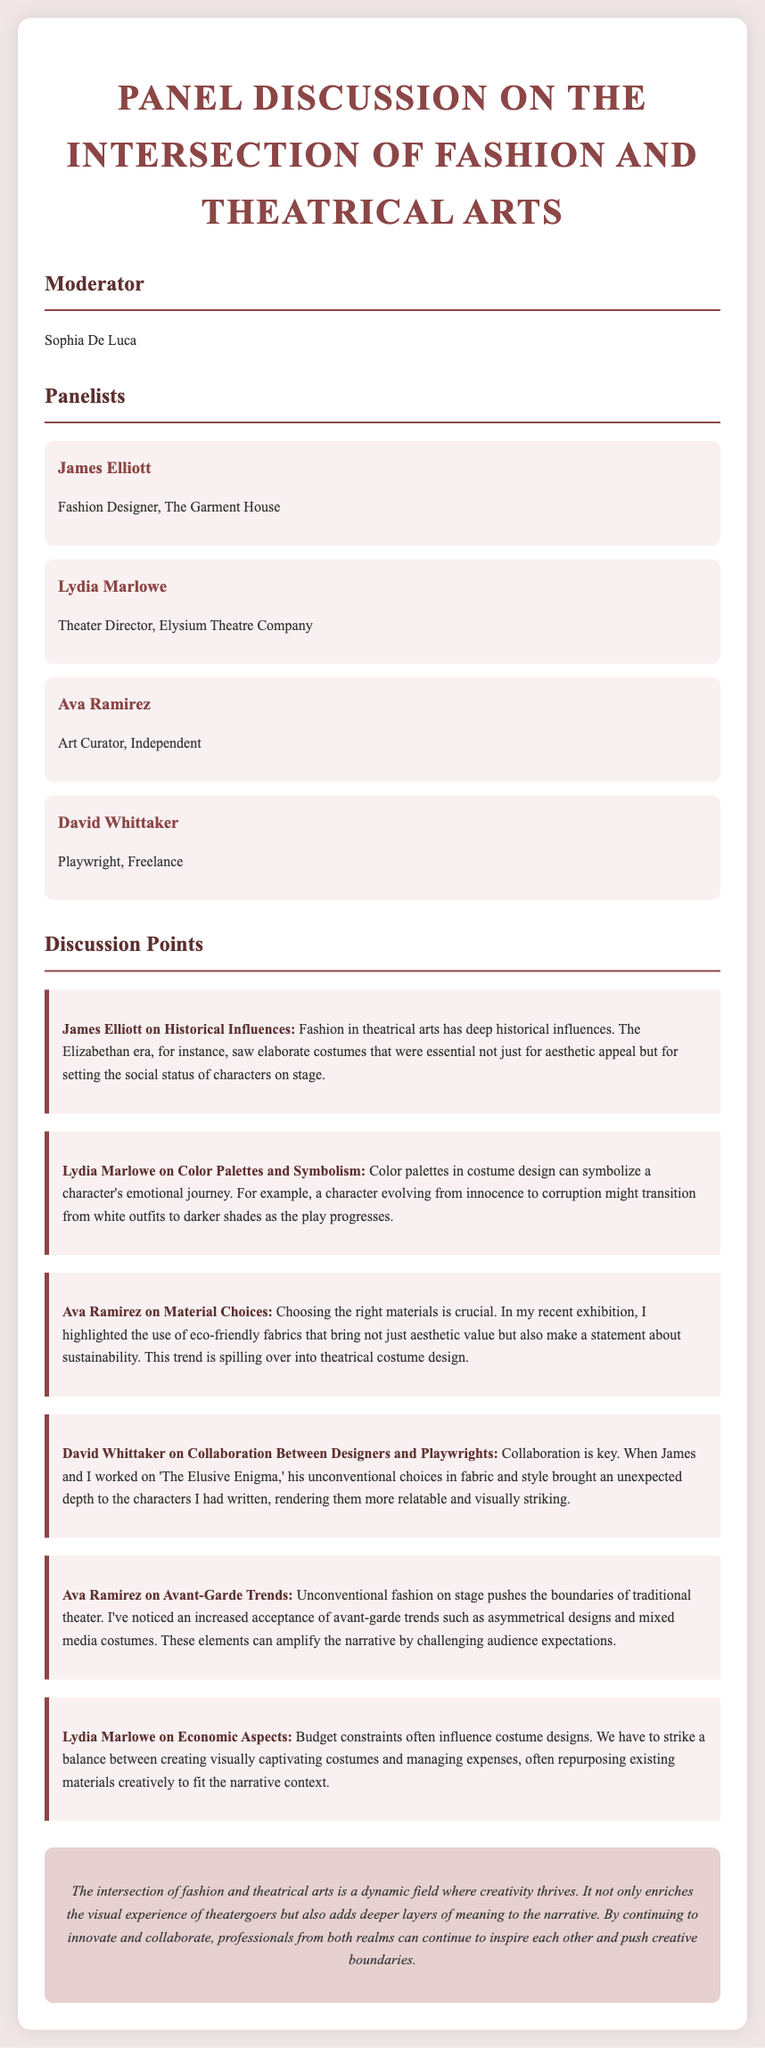What is the name of the moderator? The moderator's name is provided in the document, which is noted in the section for the moderator.
Answer: Sophia De Luca Who is the Fashion Designer panelist? The document lists the panelists, and James Elliott is identified as the Fashion Designer.
Answer: James Elliott What historical period did James Elliott reference in relation to costume design? The discussion point mentions an era that profoundly influenced theatrical costume design and is specified in the Fashion Designer's comments.
Answer: Elizabethan era What does Ava Ramirez emphasize about material choices? Ava Ramirez discusses the importance of materials and mentions a theme highlighted in her recent exhibition related to fabrics, specifically addressing the environmental aspect.
Answer: Eco-friendly fabrics Which aspect does Lydia Marlowe connect with character development through color palettes? Lydia Marlowe describes how colors can symbolize a character's emotional progress and evolution as depicted in theatrical performances.
Answer: Emotional journey What is a recent trend mentioned by Ava Ramirez in avant-garde fashion? Ava Ramirez points out specific trends in costume design that challenge traditional norms, indicating a notable style shift in theater.
Answer: Asymmetrical designs How does David Whittaker view the interaction between designers and playwrights? David Whittaker stresses the importance of collaboration between him and the designer, particularly during the creation of a specific play, which enhances the overall character portrayal.
Answer: Collaboration What is one of the constraints Lydia Marlowe mentions regarding costume design? The discussion indicates that one factor heavily affecting design choices is addressed by Lydia Marlowe, specifically related to financial management.
Answer: Budget constraints What is a key takeaway from the closing remarks of the transcript? The concluding remarks synthesize the discussion, providing an overarching theme of how combined efforts in both fields lead to innovation and influence.
Answer: Creativity thrives 